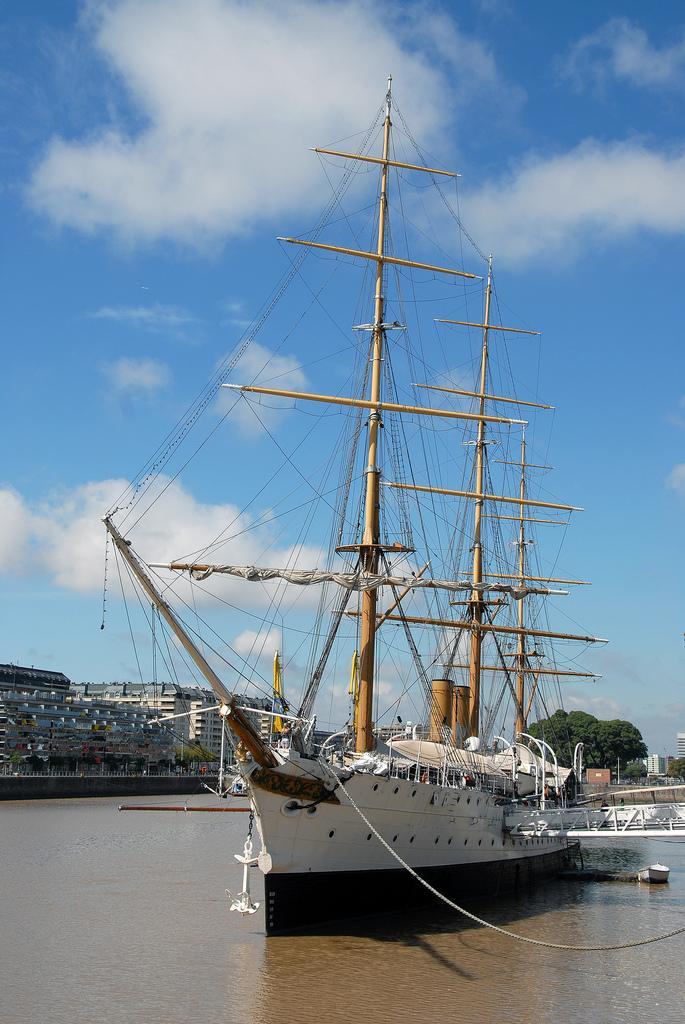Could you give a brief overview of what you see in this image? Here I can see a ship on the water. In the background, I can see many buildings and trees. At the top of the image I can see the sky and clouds. 